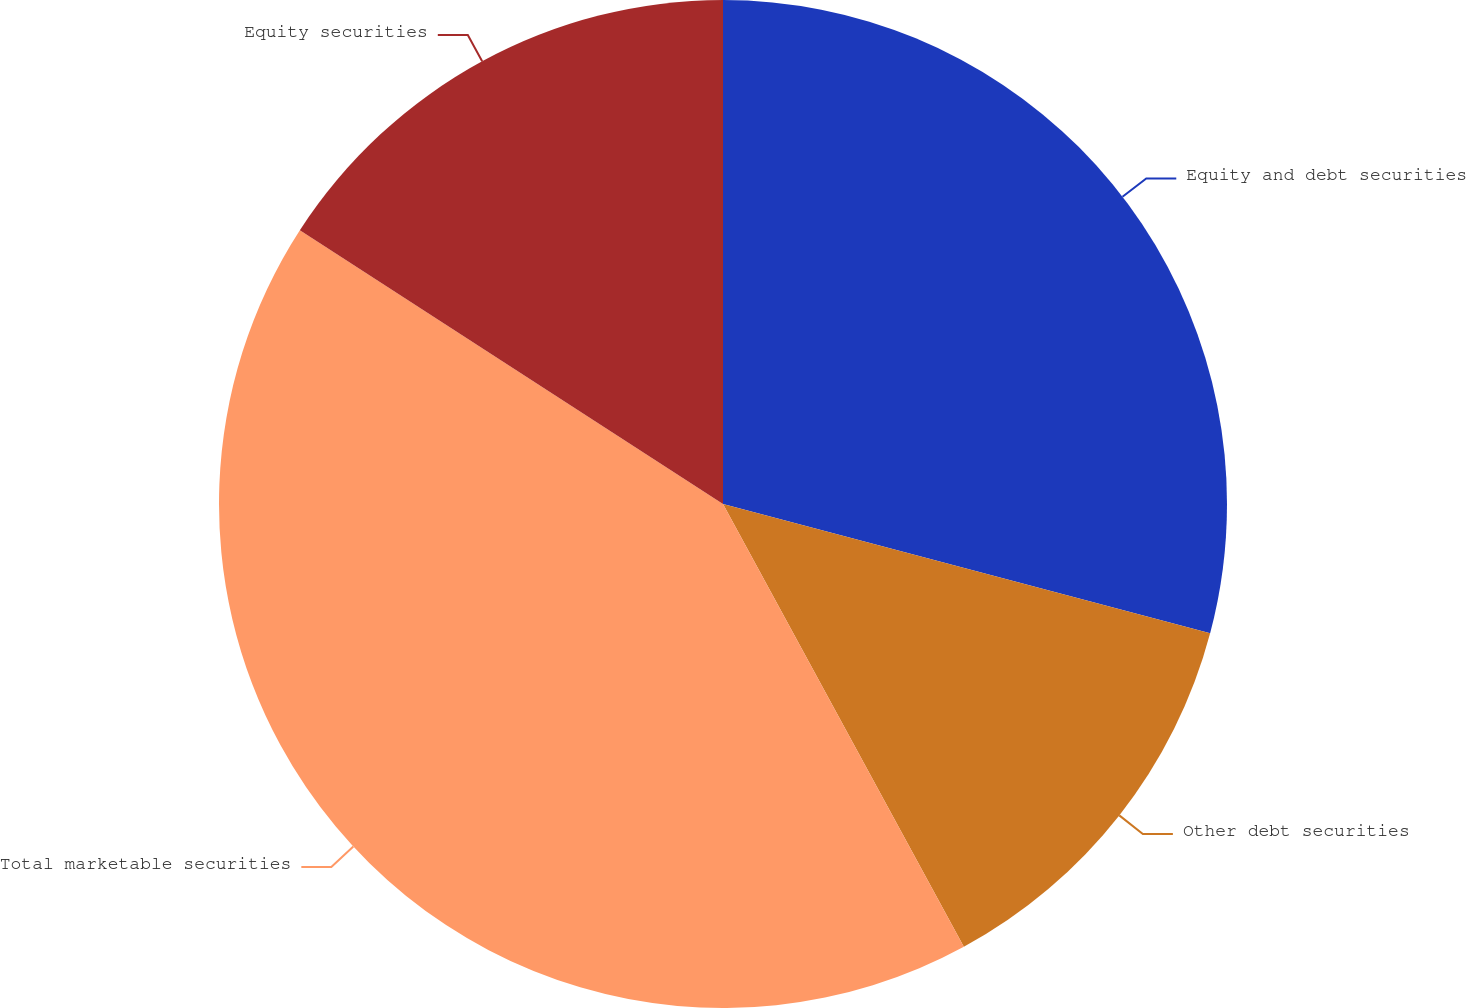Convert chart. <chart><loc_0><loc_0><loc_500><loc_500><pie_chart><fcel>Equity and debt securities<fcel>Other debt securities<fcel>Total marketable securities<fcel>Equity securities<nl><fcel>29.13%<fcel>12.94%<fcel>42.07%<fcel>15.86%<nl></chart> 